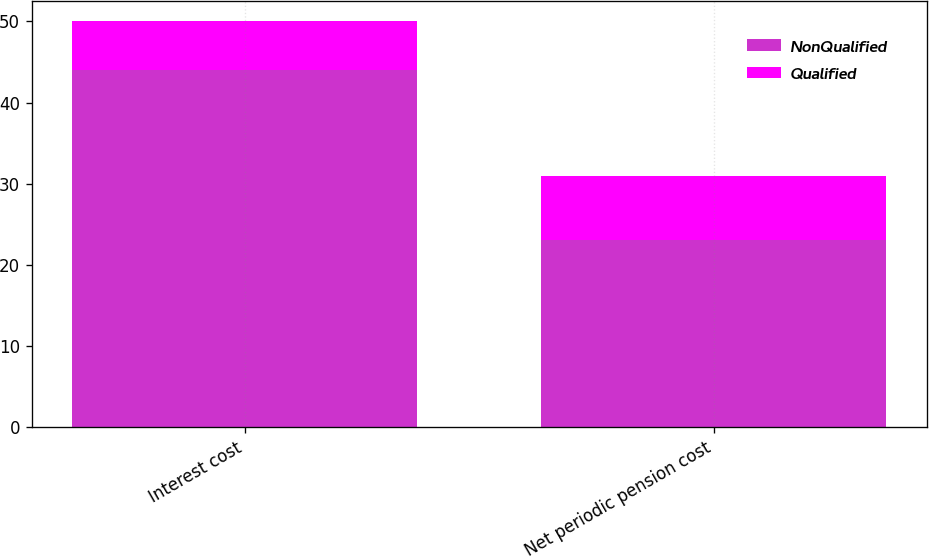Convert chart to OTSL. <chart><loc_0><loc_0><loc_500><loc_500><stacked_bar_chart><ecel><fcel>Interest cost<fcel>Net periodic pension cost<nl><fcel>NonQualified<fcel>44<fcel>23<nl><fcel>Qualified<fcel>6<fcel>8<nl></chart> 